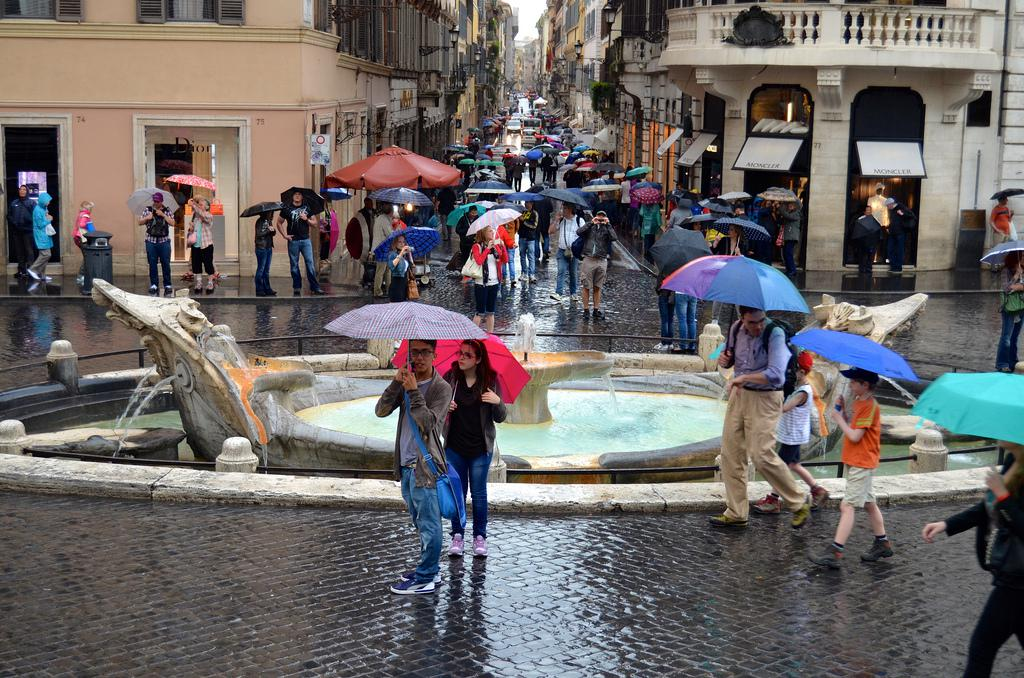Question: what is this a photo of?
Choices:
A. Children having their face painted.
B. Group of runners.
C. A crowd of people with umbrellas.
D. Soldiers in formation.
Answer with the letter. Answer: C Question: who is walking with a teal umbrella in the bottom right corner?
Choices:
A. A little boy.
B. A teacher.
C. A nurse.
D. A female.
Answer with the letter. Answer: D Question: how many people are in the photo?
Choices:
A. Five to ten.
B. Twenty-five to fifty.
C. Twenty to thirty.
D. None.
Answer with the letter. Answer: B Question: why are the people using umbrellas?
Choices:
A. Forecast for rain.
B. Planned group photo with umbrellas.
C. It is probably raining where they are.
D. As a sunshade.
Answer with the letter. Answer: C Question: what is squirting water in the center of the photo?
Choices:
A. A faulty pipeline.
B. The park fountain.
C. The broken bird fountain.
D. A water fountain.
Answer with the letter. Answer: D Question: what shape is the fountain?
Choices:
A. Rectangular.
B. Circular.
C. Star.
D. Oval.
Answer with the letter. Answer: B Question: where was this photo taken?
Choices:
A. Near forest fire.
B. Outside in the rainy streets of a city.
C. Presidential debate.
D. At Bible study.
Answer with the letter. Answer: B Question: what does the building on the right have?
Choices:
A. A light.
B. A balcony.
C. A sign.
D. A clock.
Answer with the letter. Answer: B Question: what is it doing on these people?
Choices:
A. Snowing.
B. Hailing.
C. Raining.
D. Blowing.
Answer with the letter. Answer: C Question: what condition is the street in?
Choices:
A. Wet.
B. Destroyed.
C. Dry.
D. Dirty.
Answer with the letter. Answer: A Question: what has clear water?
Choices:
A. The lake.
B. The sink.
C. The bath tub.
D. The fountain.
Answer with the letter. Answer: D Question: what are the streets paved with?
Choices:
A. Bricks.
B. Asphalt.
C. Concrete.
D. Cobblestone.
Answer with the letter. Answer: D Question: where is the orange colored building?
Choices:
A. Across the square.
B. Next to the brick bank.
C. Behind the fountain.
D. On the corner near the bus stop.
Answer with the letter. Answer: C Question: how is the road?
Choices:
A. Dry.
B. Wide.
C. Slick.
D. Safe.
Answer with the letter. Answer: C Question: what is on?
Choices:
A. The lights.
B. The television.
C. The fountain.
D. The radio.
Answer with the letter. Answer: C Question: what is the weather?
Choices:
A. Clear.
B. Sunny.
C. Rainy.
D. Stormy.
Answer with the letter. Answer: C Question: when is this taking place?
Choices:
A. Daytime.
B. During lunch.
C. After school.
D. Before work.
Answer with the letter. Answer: A 